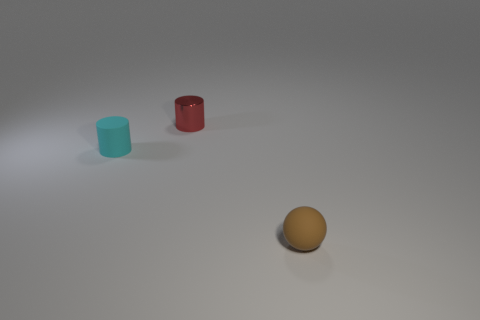Add 3 big brown metal cubes. How many objects exist? 6 Subtract all cylinders. How many objects are left? 1 Subtract all gray cubes. How many green spheres are left? 0 Add 1 small brown balls. How many small brown balls are left? 2 Add 2 yellow shiny cylinders. How many yellow shiny cylinders exist? 2 Subtract 1 cyan cylinders. How many objects are left? 2 Subtract all blue cylinders. Subtract all cyan balls. How many cylinders are left? 2 Subtract all small brown objects. Subtract all small shiny cylinders. How many objects are left? 1 